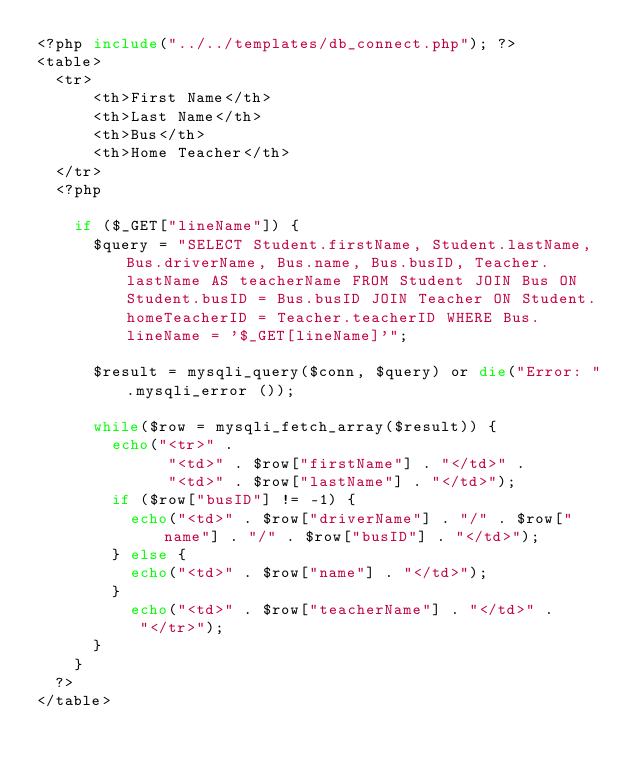Convert code to text. <code><loc_0><loc_0><loc_500><loc_500><_PHP_><?php include("../../templates/db_connect.php"); ?>
<table>
	<tr>
			<th>First Name</th>
			<th>Last Name</th>
			<th>Bus</th>
			<th>Home Teacher</th>
	</tr>
	<?php
		
		if ($_GET["lineName"]) {
			$query = "SELECT Student.firstName, Student.lastName, Bus.driverName, Bus.name, Bus.busID, Teacher.lastName AS teacherName FROM Student JOIN Bus ON Student.busID = Bus.busID JOIN Teacher ON Student.homeTeacherID = Teacher.teacherID WHERE Bus.lineName = '$_GET[lineName]'";
			
			$result = mysqli_query($conn, $query) or die("Error: ".mysqli_error ());
			
			while($row = mysqli_fetch_array($result)) {
				echo("<tr>" .
							"<td>" . $row["firstName"] . "</td>" .
							"<td>" . $row["lastName"] . "</td>");
				if ($row["busID"] != -1) {
					echo("<td>" . $row["driverName"] . "/" . $row["name"] . "/" . $row["busID"] . "</td>");
				} else {
					echo("<td>" . $row["name"] . "</td>");
				}
					echo("<td>" . $row["teacherName"] . "</td>" .
					 "</tr>");
			}
		}
	?>
</table></code> 